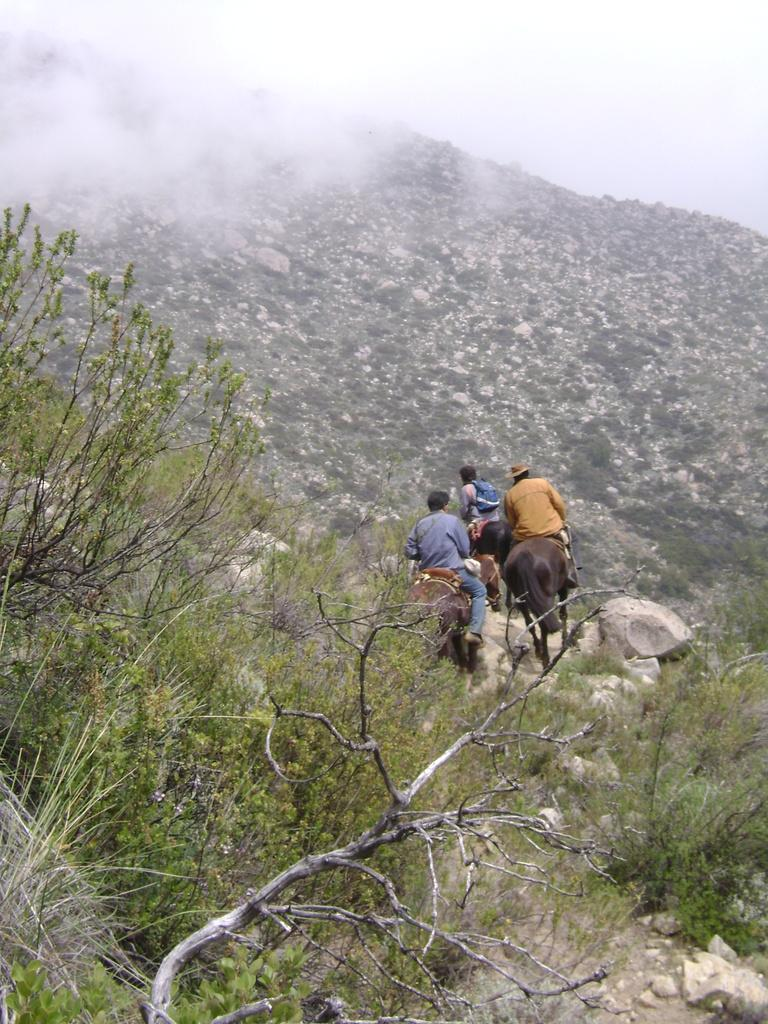How many people are in the image? There is a group of people in the image. What are the people doing in the image? The people are riding on a horse. What is the position of the horse in the image? The horse is on the ground. What can be seen in the background of the image? There is a group of trees, a mountain, and the sky visible in the background of the image. What type of bridge can be seen in the image? There is no bridge present in the image. What sound do the bells make in the image? There are no bells present in the image. 